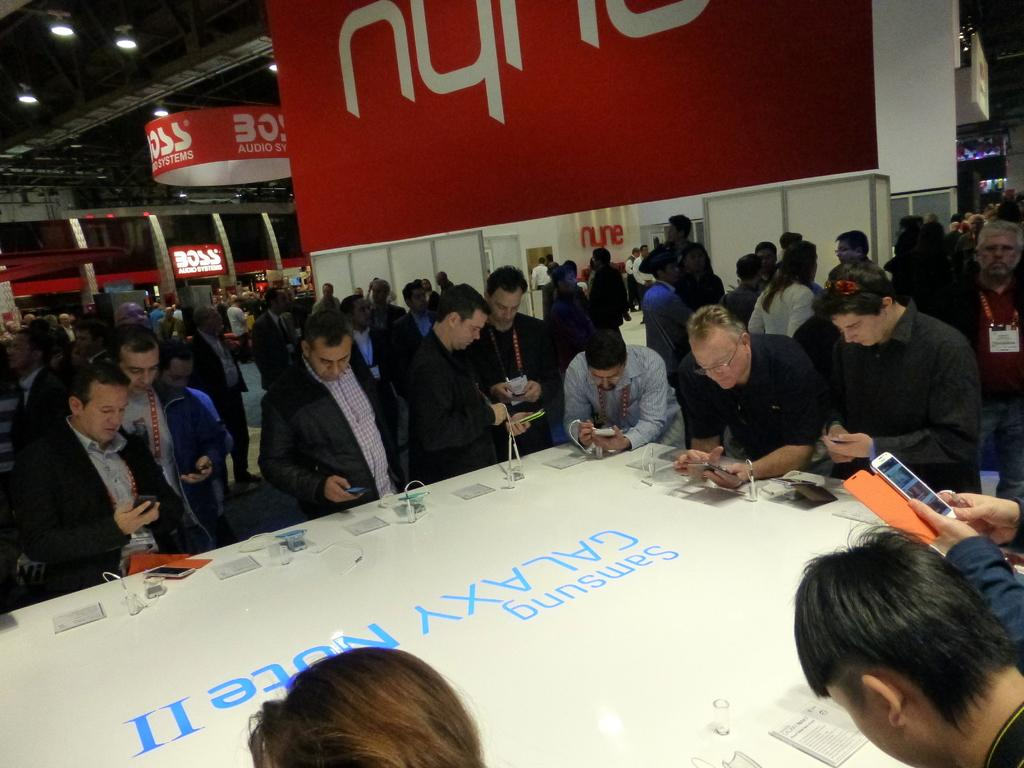What are the people in the image doing? The people in the image are standing and holding mobile phones. What can be seen in the background of the image? There is a hoarding and a board in the image. What is located at the top of the image? There are lights at the top of the image. Where is the crow sitting in the image? There is no crow present in the image. Can you describe the quilt that the people are using in the image? There is no quilt present in the image. 